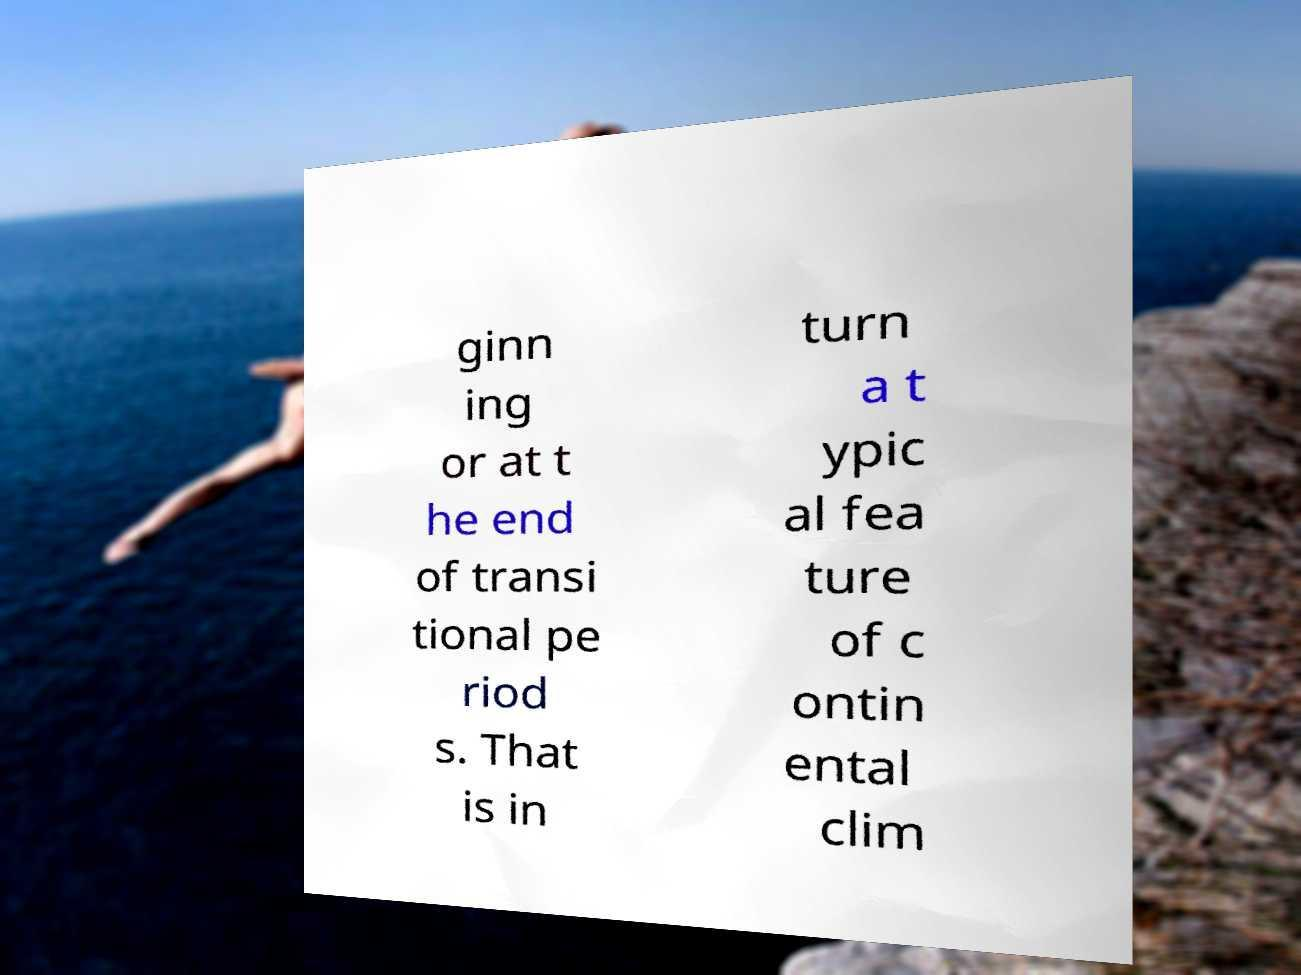Can you accurately transcribe the text from the provided image for me? ginn ing or at t he end of transi tional pe riod s. That is in turn a t ypic al fea ture of c ontin ental clim 